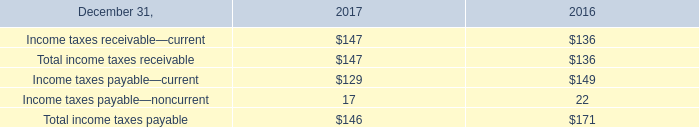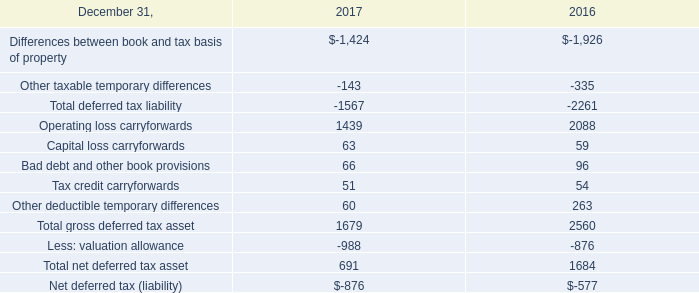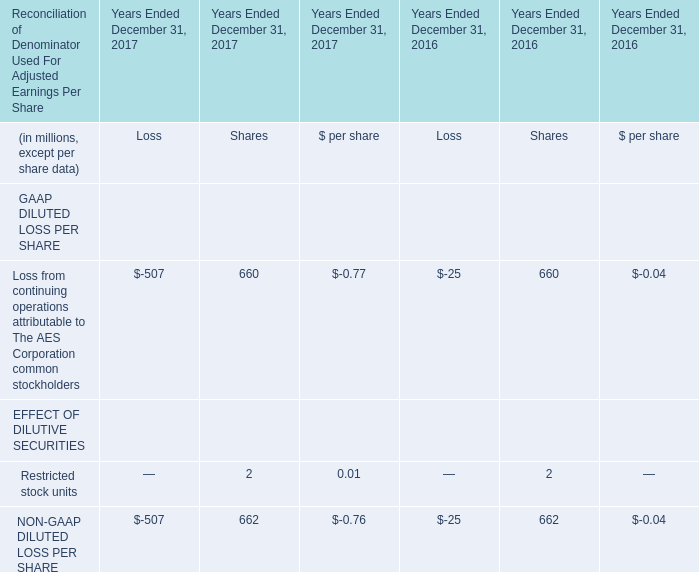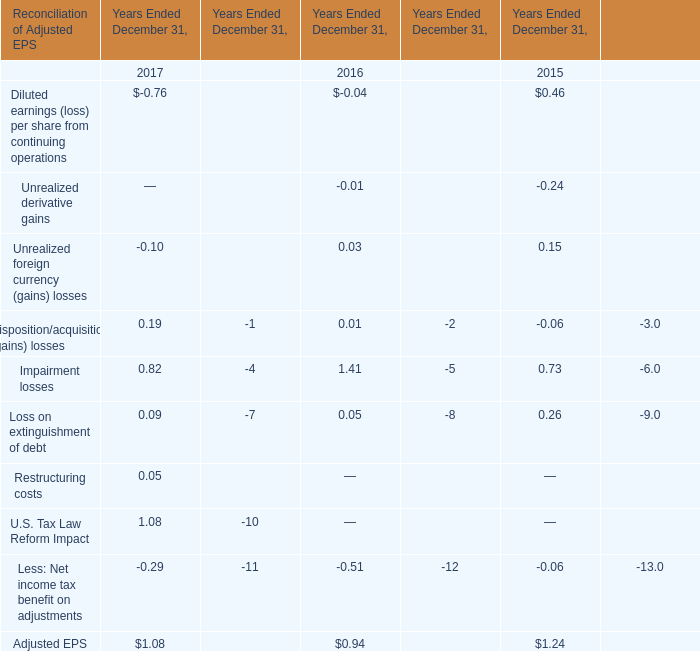Which year is Diluted earnings (loss) per share from continuing operations in table 3 greater than 0 ? 
Answer: 0.46. 